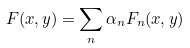Convert formula to latex. <formula><loc_0><loc_0><loc_500><loc_500>F ( x , y ) = \sum _ { n } \alpha _ { n } F _ { n } ( x , y )</formula> 